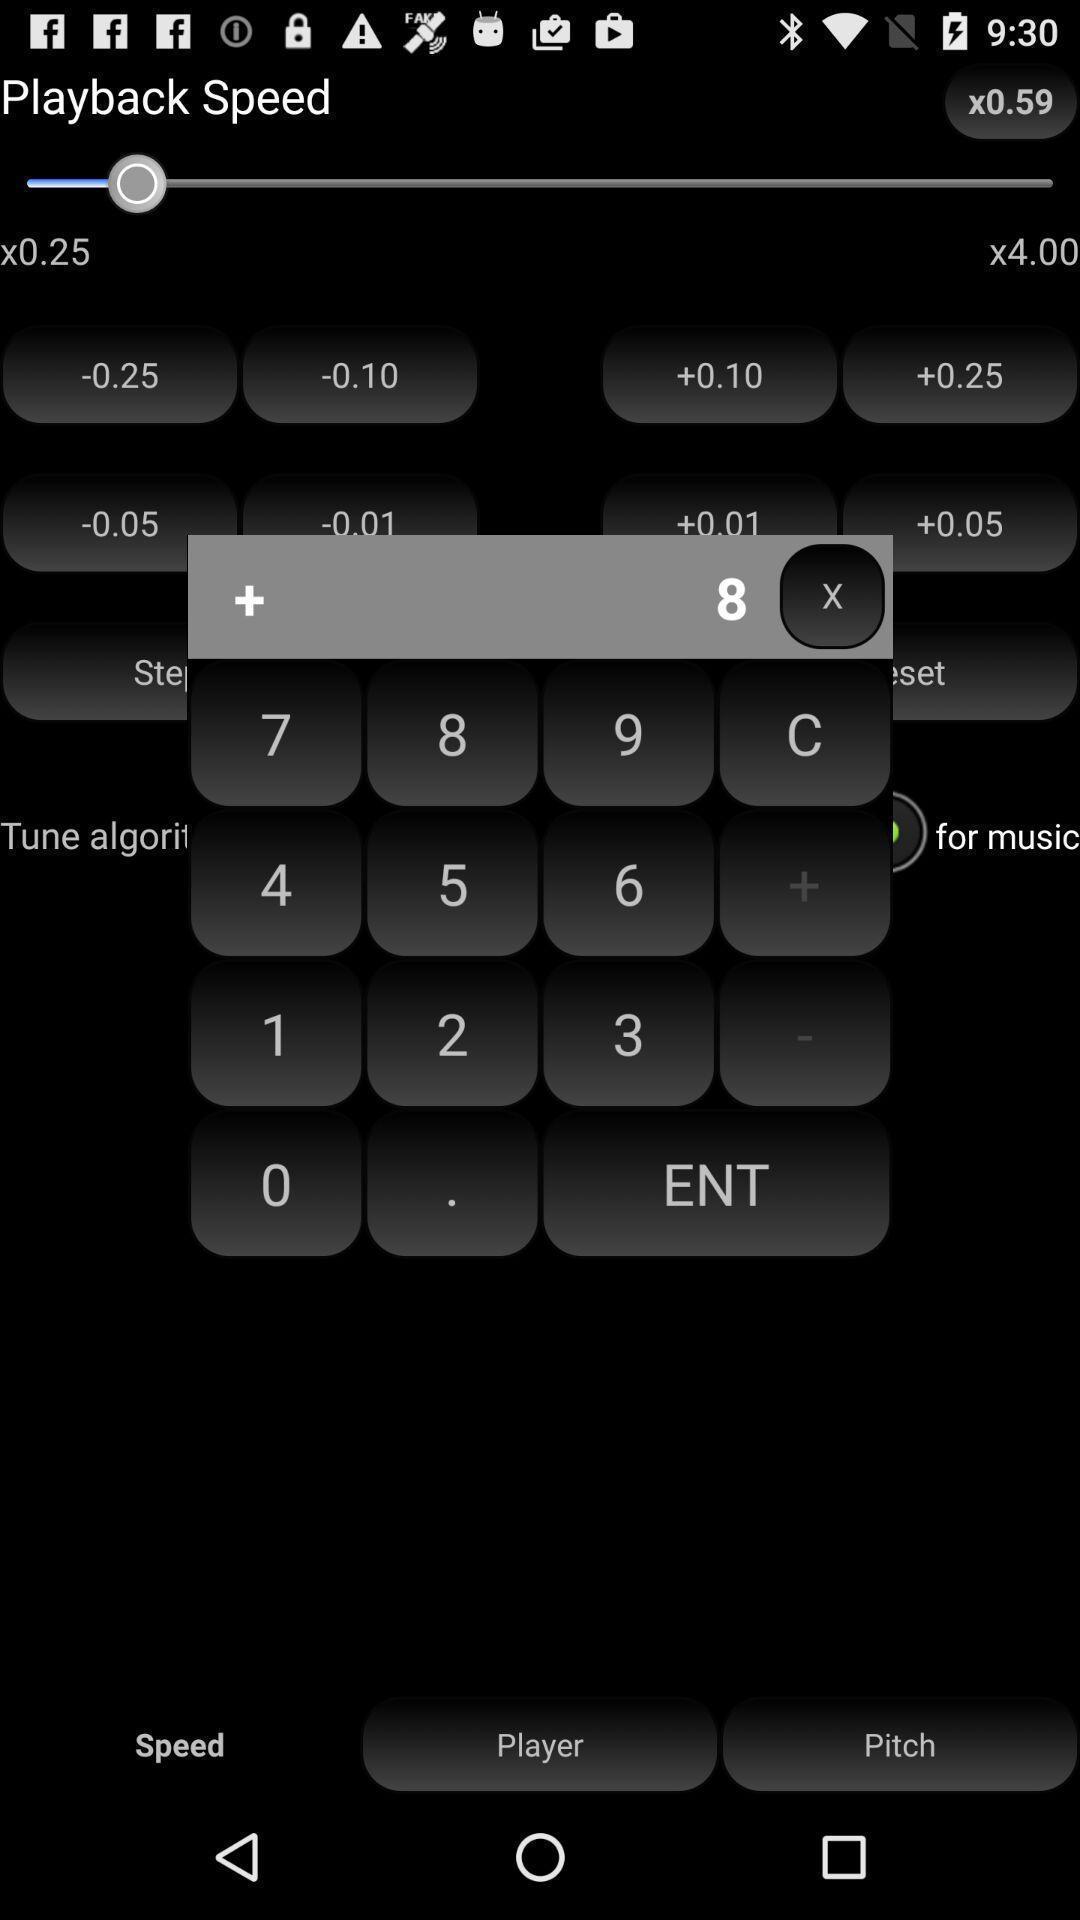What details can you identify in this image? Screen displaying calculator on an app. 